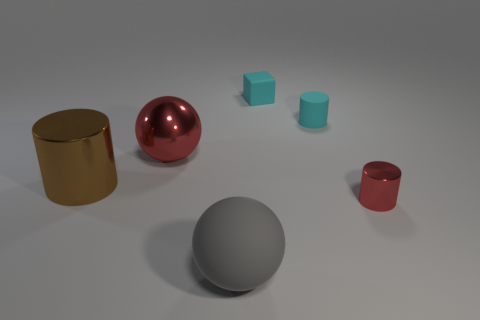Is there anything else that has the same size as the red metallic sphere?
Make the answer very short. Yes. What is the size of the cylinder that is in front of the big brown thing that is behind the shiny cylinder that is in front of the brown thing?
Give a very brief answer. Small. Is the number of gray matte spheres greater than the number of large green metallic cylinders?
Give a very brief answer. Yes. Is the material of the red object that is left of the small cyan rubber cylinder the same as the brown object?
Provide a succinct answer. Yes. Is the number of big gray rubber cylinders less than the number of large gray rubber balls?
Offer a very short reply. Yes. There is a shiny thing behind the big metal cylinder in front of the rubber cylinder; are there any small cyan cubes on the right side of it?
Your answer should be very brief. Yes. Is the shape of the large shiny object in front of the large shiny sphere the same as  the big red metal thing?
Make the answer very short. No. Are there more tiny red metal cylinders that are in front of the gray matte thing than large gray metallic cylinders?
Your answer should be compact. No. There is a small thing in front of the cyan matte cylinder; is its color the same as the large metallic cylinder?
Offer a terse response. No. Is there any other thing of the same color as the matte cylinder?
Your response must be concise. Yes. 